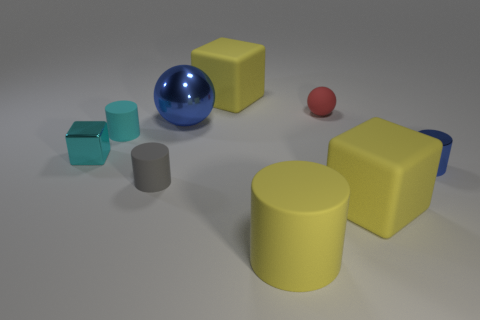Subtract 1 cubes. How many cubes are left? 2 Subtract all brown cylinders. Subtract all green cubes. How many cylinders are left? 4 Subtract all cubes. How many objects are left? 6 Subtract 1 red spheres. How many objects are left? 8 Subtract all big purple cubes. Subtract all small rubber balls. How many objects are left? 8 Add 4 blue cylinders. How many blue cylinders are left? 5 Add 8 red rubber things. How many red rubber things exist? 9 